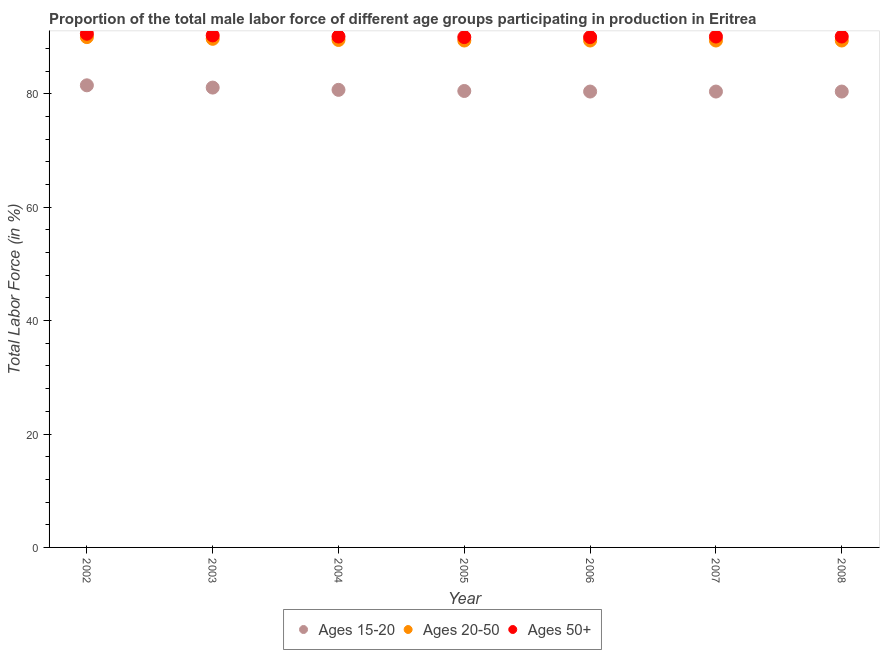How many different coloured dotlines are there?
Offer a very short reply. 3. Is the number of dotlines equal to the number of legend labels?
Keep it short and to the point. Yes. What is the percentage of male labor force within the age group 15-20 in 2007?
Give a very brief answer. 80.4. Across all years, what is the minimum percentage of male labor force within the age group 20-50?
Keep it short and to the point. 89.4. What is the total percentage of male labor force within the age group 20-50 in the graph?
Offer a very short reply. 626.8. What is the difference between the percentage of male labor force within the age group 15-20 in 2005 and that in 2006?
Provide a succinct answer. 0.1. What is the difference between the percentage of male labor force above age 50 in 2003 and the percentage of male labor force within the age group 20-50 in 2005?
Your answer should be compact. 0.9. What is the average percentage of male labor force above age 50 per year?
Provide a succinct answer. 90.17. In the year 2003, what is the difference between the percentage of male labor force above age 50 and percentage of male labor force within the age group 15-20?
Your answer should be compact. 9.2. What is the ratio of the percentage of male labor force within the age group 20-50 in 2002 to that in 2004?
Keep it short and to the point. 1.01. Is the difference between the percentage of male labor force within the age group 20-50 in 2002 and 2005 greater than the difference between the percentage of male labor force above age 50 in 2002 and 2005?
Give a very brief answer. Yes. What is the difference between the highest and the second highest percentage of male labor force above age 50?
Keep it short and to the point. 0.3. What is the difference between the highest and the lowest percentage of male labor force within the age group 20-50?
Provide a short and direct response. 0.6. Is it the case that in every year, the sum of the percentage of male labor force within the age group 15-20 and percentage of male labor force within the age group 20-50 is greater than the percentage of male labor force above age 50?
Offer a terse response. Yes. Does the percentage of male labor force above age 50 monotonically increase over the years?
Provide a succinct answer. No. Does the graph contain grids?
Provide a short and direct response. No. Where does the legend appear in the graph?
Your response must be concise. Bottom center. How many legend labels are there?
Your response must be concise. 3. What is the title of the graph?
Offer a very short reply. Proportion of the total male labor force of different age groups participating in production in Eritrea. Does "Fuel" appear as one of the legend labels in the graph?
Your answer should be compact. No. What is the Total Labor Force (in %) in Ages 15-20 in 2002?
Offer a terse response. 81.5. What is the Total Labor Force (in %) in Ages 20-50 in 2002?
Offer a very short reply. 90. What is the Total Labor Force (in %) in Ages 50+ in 2002?
Offer a very short reply. 90.6. What is the Total Labor Force (in %) in Ages 15-20 in 2003?
Offer a terse response. 81.1. What is the Total Labor Force (in %) of Ages 20-50 in 2003?
Ensure brevity in your answer.  89.7. What is the Total Labor Force (in %) in Ages 50+ in 2003?
Keep it short and to the point. 90.3. What is the Total Labor Force (in %) of Ages 15-20 in 2004?
Give a very brief answer. 80.7. What is the Total Labor Force (in %) in Ages 20-50 in 2004?
Provide a succinct answer. 89.5. What is the Total Labor Force (in %) of Ages 50+ in 2004?
Your answer should be compact. 90.1. What is the Total Labor Force (in %) of Ages 15-20 in 2005?
Your response must be concise. 80.5. What is the Total Labor Force (in %) in Ages 20-50 in 2005?
Provide a short and direct response. 89.4. What is the Total Labor Force (in %) of Ages 15-20 in 2006?
Make the answer very short. 80.4. What is the Total Labor Force (in %) of Ages 20-50 in 2006?
Give a very brief answer. 89.4. What is the Total Labor Force (in %) of Ages 15-20 in 2007?
Keep it short and to the point. 80.4. What is the Total Labor Force (in %) in Ages 20-50 in 2007?
Your answer should be very brief. 89.4. What is the Total Labor Force (in %) of Ages 50+ in 2007?
Offer a very short reply. 90.1. What is the Total Labor Force (in %) in Ages 15-20 in 2008?
Offer a terse response. 80.4. What is the Total Labor Force (in %) in Ages 20-50 in 2008?
Give a very brief answer. 89.4. What is the Total Labor Force (in %) of Ages 50+ in 2008?
Offer a terse response. 90.1. Across all years, what is the maximum Total Labor Force (in %) of Ages 15-20?
Your response must be concise. 81.5. Across all years, what is the maximum Total Labor Force (in %) in Ages 50+?
Ensure brevity in your answer.  90.6. Across all years, what is the minimum Total Labor Force (in %) of Ages 15-20?
Ensure brevity in your answer.  80.4. Across all years, what is the minimum Total Labor Force (in %) in Ages 20-50?
Make the answer very short. 89.4. Across all years, what is the minimum Total Labor Force (in %) of Ages 50+?
Ensure brevity in your answer.  90. What is the total Total Labor Force (in %) in Ages 15-20 in the graph?
Keep it short and to the point. 565. What is the total Total Labor Force (in %) in Ages 20-50 in the graph?
Offer a terse response. 626.8. What is the total Total Labor Force (in %) of Ages 50+ in the graph?
Keep it short and to the point. 631.2. What is the difference between the Total Labor Force (in %) in Ages 15-20 in 2002 and that in 2003?
Ensure brevity in your answer.  0.4. What is the difference between the Total Labor Force (in %) in Ages 20-50 in 2002 and that in 2003?
Offer a terse response. 0.3. What is the difference between the Total Labor Force (in %) of Ages 15-20 in 2002 and that in 2004?
Offer a terse response. 0.8. What is the difference between the Total Labor Force (in %) in Ages 50+ in 2002 and that in 2004?
Make the answer very short. 0.5. What is the difference between the Total Labor Force (in %) in Ages 20-50 in 2002 and that in 2005?
Provide a succinct answer. 0.6. What is the difference between the Total Labor Force (in %) of Ages 20-50 in 2002 and that in 2006?
Provide a short and direct response. 0.6. What is the difference between the Total Labor Force (in %) of Ages 15-20 in 2002 and that in 2008?
Your answer should be compact. 1.1. What is the difference between the Total Labor Force (in %) in Ages 20-50 in 2002 and that in 2008?
Your response must be concise. 0.6. What is the difference between the Total Labor Force (in %) in Ages 50+ in 2002 and that in 2008?
Provide a short and direct response. 0.5. What is the difference between the Total Labor Force (in %) in Ages 15-20 in 2003 and that in 2004?
Give a very brief answer. 0.4. What is the difference between the Total Labor Force (in %) of Ages 20-50 in 2003 and that in 2005?
Give a very brief answer. 0.3. What is the difference between the Total Labor Force (in %) in Ages 50+ in 2003 and that in 2005?
Give a very brief answer. 0.3. What is the difference between the Total Labor Force (in %) of Ages 20-50 in 2003 and that in 2006?
Your answer should be very brief. 0.3. What is the difference between the Total Labor Force (in %) in Ages 50+ in 2003 and that in 2006?
Offer a terse response. 0.3. What is the difference between the Total Labor Force (in %) in Ages 20-50 in 2003 and that in 2007?
Provide a succinct answer. 0.3. What is the difference between the Total Labor Force (in %) in Ages 50+ in 2003 and that in 2007?
Make the answer very short. 0.2. What is the difference between the Total Labor Force (in %) of Ages 20-50 in 2003 and that in 2008?
Make the answer very short. 0.3. What is the difference between the Total Labor Force (in %) in Ages 20-50 in 2004 and that in 2006?
Keep it short and to the point. 0.1. What is the difference between the Total Labor Force (in %) of Ages 50+ in 2004 and that in 2006?
Ensure brevity in your answer.  0.1. What is the difference between the Total Labor Force (in %) of Ages 15-20 in 2004 and that in 2007?
Offer a terse response. 0.3. What is the difference between the Total Labor Force (in %) in Ages 15-20 in 2004 and that in 2008?
Provide a short and direct response. 0.3. What is the difference between the Total Labor Force (in %) of Ages 50+ in 2004 and that in 2008?
Your response must be concise. 0. What is the difference between the Total Labor Force (in %) of Ages 15-20 in 2005 and that in 2006?
Provide a short and direct response. 0.1. What is the difference between the Total Labor Force (in %) in Ages 15-20 in 2005 and that in 2007?
Your answer should be compact. 0.1. What is the difference between the Total Labor Force (in %) of Ages 15-20 in 2005 and that in 2008?
Make the answer very short. 0.1. What is the difference between the Total Labor Force (in %) in Ages 50+ in 2005 and that in 2008?
Provide a short and direct response. -0.1. What is the difference between the Total Labor Force (in %) of Ages 15-20 in 2006 and that in 2008?
Your answer should be compact. 0. What is the difference between the Total Labor Force (in %) of Ages 50+ in 2006 and that in 2008?
Your answer should be very brief. -0.1. What is the difference between the Total Labor Force (in %) in Ages 15-20 in 2002 and the Total Labor Force (in %) in Ages 20-50 in 2003?
Your response must be concise. -8.2. What is the difference between the Total Labor Force (in %) of Ages 15-20 in 2002 and the Total Labor Force (in %) of Ages 50+ in 2003?
Your response must be concise. -8.8. What is the difference between the Total Labor Force (in %) of Ages 20-50 in 2002 and the Total Labor Force (in %) of Ages 50+ in 2003?
Offer a terse response. -0.3. What is the difference between the Total Labor Force (in %) of Ages 20-50 in 2002 and the Total Labor Force (in %) of Ages 50+ in 2005?
Your response must be concise. 0. What is the difference between the Total Labor Force (in %) in Ages 15-20 in 2002 and the Total Labor Force (in %) in Ages 20-50 in 2006?
Keep it short and to the point. -7.9. What is the difference between the Total Labor Force (in %) in Ages 20-50 in 2002 and the Total Labor Force (in %) in Ages 50+ in 2006?
Keep it short and to the point. 0. What is the difference between the Total Labor Force (in %) in Ages 15-20 in 2002 and the Total Labor Force (in %) in Ages 20-50 in 2007?
Your answer should be very brief. -7.9. What is the difference between the Total Labor Force (in %) in Ages 15-20 in 2002 and the Total Labor Force (in %) in Ages 50+ in 2007?
Offer a very short reply. -8.6. What is the difference between the Total Labor Force (in %) in Ages 20-50 in 2002 and the Total Labor Force (in %) in Ages 50+ in 2007?
Provide a short and direct response. -0.1. What is the difference between the Total Labor Force (in %) in Ages 20-50 in 2002 and the Total Labor Force (in %) in Ages 50+ in 2008?
Keep it short and to the point. -0.1. What is the difference between the Total Labor Force (in %) in Ages 15-20 in 2003 and the Total Labor Force (in %) in Ages 20-50 in 2004?
Give a very brief answer. -8.4. What is the difference between the Total Labor Force (in %) in Ages 15-20 in 2003 and the Total Labor Force (in %) in Ages 50+ in 2004?
Your response must be concise. -9. What is the difference between the Total Labor Force (in %) in Ages 20-50 in 2003 and the Total Labor Force (in %) in Ages 50+ in 2004?
Ensure brevity in your answer.  -0.4. What is the difference between the Total Labor Force (in %) of Ages 15-20 in 2003 and the Total Labor Force (in %) of Ages 20-50 in 2005?
Your answer should be very brief. -8.3. What is the difference between the Total Labor Force (in %) of Ages 20-50 in 2003 and the Total Labor Force (in %) of Ages 50+ in 2005?
Offer a very short reply. -0.3. What is the difference between the Total Labor Force (in %) of Ages 15-20 in 2003 and the Total Labor Force (in %) of Ages 20-50 in 2006?
Your answer should be very brief. -8.3. What is the difference between the Total Labor Force (in %) in Ages 15-20 in 2003 and the Total Labor Force (in %) in Ages 50+ in 2006?
Your response must be concise. -8.9. What is the difference between the Total Labor Force (in %) in Ages 20-50 in 2003 and the Total Labor Force (in %) in Ages 50+ in 2006?
Your response must be concise. -0.3. What is the difference between the Total Labor Force (in %) of Ages 15-20 in 2003 and the Total Labor Force (in %) of Ages 50+ in 2007?
Your answer should be compact. -9. What is the difference between the Total Labor Force (in %) of Ages 15-20 in 2003 and the Total Labor Force (in %) of Ages 20-50 in 2008?
Offer a terse response. -8.3. What is the difference between the Total Labor Force (in %) in Ages 15-20 in 2003 and the Total Labor Force (in %) in Ages 50+ in 2008?
Offer a terse response. -9. What is the difference between the Total Labor Force (in %) in Ages 20-50 in 2003 and the Total Labor Force (in %) in Ages 50+ in 2008?
Your answer should be very brief. -0.4. What is the difference between the Total Labor Force (in %) in Ages 15-20 in 2004 and the Total Labor Force (in %) in Ages 50+ in 2005?
Provide a short and direct response. -9.3. What is the difference between the Total Labor Force (in %) of Ages 20-50 in 2004 and the Total Labor Force (in %) of Ages 50+ in 2005?
Make the answer very short. -0.5. What is the difference between the Total Labor Force (in %) of Ages 20-50 in 2004 and the Total Labor Force (in %) of Ages 50+ in 2006?
Make the answer very short. -0.5. What is the difference between the Total Labor Force (in %) of Ages 15-20 in 2004 and the Total Labor Force (in %) of Ages 20-50 in 2007?
Give a very brief answer. -8.7. What is the difference between the Total Labor Force (in %) of Ages 20-50 in 2004 and the Total Labor Force (in %) of Ages 50+ in 2007?
Make the answer very short. -0.6. What is the difference between the Total Labor Force (in %) in Ages 20-50 in 2004 and the Total Labor Force (in %) in Ages 50+ in 2008?
Your answer should be compact. -0.6. What is the difference between the Total Labor Force (in %) in Ages 20-50 in 2005 and the Total Labor Force (in %) in Ages 50+ in 2006?
Your answer should be compact. -0.6. What is the difference between the Total Labor Force (in %) of Ages 15-20 in 2005 and the Total Labor Force (in %) of Ages 20-50 in 2007?
Your response must be concise. -8.9. What is the difference between the Total Labor Force (in %) in Ages 20-50 in 2005 and the Total Labor Force (in %) in Ages 50+ in 2007?
Your answer should be very brief. -0.7. What is the difference between the Total Labor Force (in %) of Ages 15-20 in 2005 and the Total Labor Force (in %) of Ages 50+ in 2008?
Your response must be concise. -9.6. What is the difference between the Total Labor Force (in %) in Ages 15-20 in 2006 and the Total Labor Force (in %) in Ages 20-50 in 2007?
Make the answer very short. -9. What is the difference between the Total Labor Force (in %) of Ages 15-20 in 2006 and the Total Labor Force (in %) of Ages 50+ in 2008?
Offer a very short reply. -9.7. What is the difference between the Total Labor Force (in %) of Ages 20-50 in 2006 and the Total Labor Force (in %) of Ages 50+ in 2008?
Keep it short and to the point. -0.7. What is the difference between the Total Labor Force (in %) in Ages 15-20 in 2007 and the Total Labor Force (in %) in Ages 50+ in 2008?
Ensure brevity in your answer.  -9.7. What is the average Total Labor Force (in %) in Ages 15-20 per year?
Your response must be concise. 80.71. What is the average Total Labor Force (in %) in Ages 20-50 per year?
Keep it short and to the point. 89.54. What is the average Total Labor Force (in %) of Ages 50+ per year?
Provide a short and direct response. 90.17. In the year 2002, what is the difference between the Total Labor Force (in %) in Ages 15-20 and Total Labor Force (in %) in Ages 50+?
Your answer should be compact. -9.1. In the year 2002, what is the difference between the Total Labor Force (in %) of Ages 20-50 and Total Labor Force (in %) of Ages 50+?
Give a very brief answer. -0.6. In the year 2004, what is the difference between the Total Labor Force (in %) in Ages 15-20 and Total Labor Force (in %) in Ages 50+?
Make the answer very short. -9.4. In the year 2004, what is the difference between the Total Labor Force (in %) of Ages 20-50 and Total Labor Force (in %) of Ages 50+?
Your response must be concise. -0.6. In the year 2005, what is the difference between the Total Labor Force (in %) of Ages 15-20 and Total Labor Force (in %) of Ages 20-50?
Ensure brevity in your answer.  -8.9. In the year 2006, what is the difference between the Total Labor Force (in %) of Ages 15-20 and Total Labor Force (in %) of Ages 50+?
Provide a short and direct response. -9.6. In the year 2006, what is the difference between the Total Labor Force (in %) in Ages 20-50 and Total Labor Force (in %) in Ages 50+?
Your response must be concise. -0.6. In the year 2007, what is the difference between the Total Labor Force (in %) in Ages 15-20 and Total Labor Force (in %) in Ages 20-50?
Your answer should be very brief. -9. In the year 2007, what is the difference between the Total Labor Force (in %) of Ages 15-20 and Total Labor Force (in %) of Ages 50+?
Offer a terse response. -9.7. In the year 2008, what is the difference between the Total Labor Force (in %) of Ages 20-50 and Total Labor Force (in %) of Ages 50+?
Offer a very short reply. -0.7. What is the ratio of the Total Labor Force (in %) in Ages 15-20 in 2002 to that in 2003?
Your answer should be very brief. 1. What is the ratio of the Total Labor Force (in %) of Ages 20-50 in 2002 to that in 2003?
Your answer should be compact. 1. What is the ratio of the Total Labor Force (in %) of Ages 50+ in 2002 to that in 2003?
Your answer should be compact. 1. What is the ratio of the Total Labor Force (in %) of Ages 15-20 in 2002 to that in 2004?
Your answer should be very brief. 1.01. What is the ratio of the Total Labor Force (in %) in Ages 20-50 in 2002 to that in 2004?
Offer a terse response. 1.01. What is the ratio of the Total Labor Force (in %) in Ages 15-20 in 2002 to that in 2005?
Make the answer very short. 1.01. What is the ratio of the Total Labor Force (in %) of Ages 50+ in 2002 to that in 2005?
Your response must be concise. 1.01. What is the ratio of the Total Labor Force (in %) of Ages 15-20 in 2002 to that in 2006?
Provide a succinct answer. 1.01. What is the ratio of the Total Labor Force (in %) of Ages 15-20 in 2002 to that in 2007?
Keep it short and to the point. 1.01. What is the ratio of the Total Labor Force (in %) in Ages 20-50 in 2002 to that in 2007?
Ensure brevity in your answer.  1.01. What is the ratio of the Total Labor Force (in %) of Ages 50+ in 2002 to that in 2007?
Give a very brief answer. 1.01. What is the ratio of the Total Labor Force (in %) in Ages 15-20 in 2002 to that in 2008?
Your response must be concise. 1.01. What is the ratio of the Total Labor Force (in %) of Ages 20-50 in 2002 to that in 2008?
Offer a terse response. 1.01. What is the ratio of the Total Labor Force (in %) in Ages 15-20 in 2003 to that in 2004?
Make the answer very short. 1. What is the ratio of the Total Labor Force (in %) of Ages 20-50 in 2003 to that in 2004?
Provide a succinct answer. 1. What is the ratio of the Total Labor Force (in %) in Ages 15-20 in 2003 to that in 2005?
Your answer should be compact. 1.01. What is the ratio of the Total Labor Force (in %) of Ages 15-20 in 2003 to that in 2006?
Offer a very short reply. 1.01. What is the ratio of the Total Labor Force (in %) of Ages 20-50 in 2003 to that in 2006?
Your answer should be compact. 1. What is the ratio of the Total Labor Force (in %) of Ages 50+ in 2003 to that in 2006?
Provide a short and direct response. 1. What is the ratio of the Total Labor Force (in %) in Ages 15-20 in 2003 to that in 2007?
Give a very brief answer. 1.01. What is the ratio of the Total Labor Force (in %) in Ages 50+ in 2003 to that in 2007?
Give a very brief answer. 1. What is the ratio of the Total Labor Force (in %) of Ages 15-20 in 2003 to that in 2008?
Give a very brief answer. 1.01. What is the ratio of the Total Labor Force (in %) of Ages 50+ in 2003 to that in 2008?
Provide a succinct answer. 1. What is the ratio of the Total Labor Force (in %) of Ages 15-20 in 2004 to that in 2005?
Provide a succinct answer. 1. What is the ratio of the Total Labor Force (in %) of Ages 50+ in 2004 to that in 2005?
Offer a terse response. 1. What is the ratio of the Total Labor Force (in %) in Ages 15-20 in 2004 to that in 2007?
Keep it short and to the point. 1. What is the ratio of the Total Labor Force (in %) of Ages 20-50 in 2004 to that in 2007?
Your response must be concise. 1. What is the ratio of the Total Labor Force (in %) of Ages 50+ in 2004 to that in 2008?
Your answer should be compact. 1. What is the ratio of the Total Labor Force (in %) of Ages 50+ in 2005 to that in 2006?
Your answer should be compact. 1. What is the ratio of the Total Labor Force (in %) of Ages 15-20 in 2005 to that in 2007?
Offer a very short reply. 1. What is the ratio of the Total Labor Force (in %) in Ages 20-50 in 2005 to that in 2007?
Give a very brief answer. 1. What is the ratio of the Total Labor Force (in %) in Ages 50+ in 2005 to that in 2007?
Provide a short and direct response. 1. What is the ratio of the Total Labor Force (in %) of Ages 20-50 in 2005 to that in 2008?
Offer a terse response. 1. What is the ratio of the Total Labor Force (in %) of Ages 50+ in 2005 to that in 2008?
Offer a terse response. 1. What is the ratio of the Total Labor Force (in %) in Ages 20-50 in 2006 to that in 2007?
Give a very brief answer. 1. What is the ratio of the Total Labor Force (in %) in Ages 15-20 in 2006 to that in 2008?
Your answer should be very brief. 1. What is the ratio of the Total Labor Force (in %) in Ages 20-50 in 2007 to that in 2008?
Your answer should be very brief. 1. What is the difference between the highest and the second highest Total Labor Force (in %) of Ages 15-20?
Offer a terse response. 0.4. What is the difference between the highest and the lowest Total Labor Force (in %) of Ages 15-20?
Your answer should be compact. 1.1. 